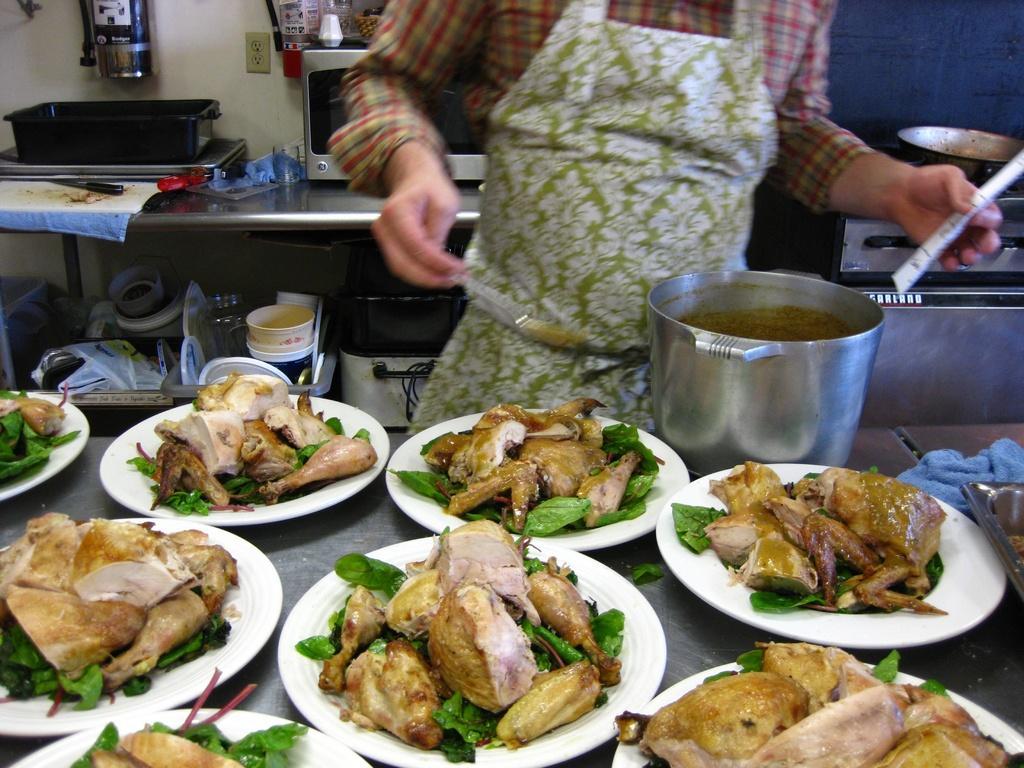Could you give a brief overview of what you see in this image? In this image I can see a person wearing shirt is standing in front of a table and on the table I can see number of white colored plates which chicken pieces and herbs in them. I can see a container, a cloth and a tray on the table. I can see the person is holding a spoon and a white colored object in his hands. In the background I can see a gas stove, a bowl on the gas stove, a microwave oven, a black colored box and few other objects. 